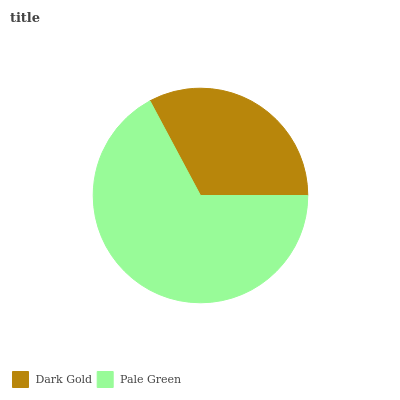Is Dark Gold the minimum?
Answer yes or no. Yes. Is Pale Green the maximum?
Answer yes or no. Yes. Is Pale Green the minimum?
Answer yes or no. No. Is Pale Green greater than Dark Gold?
Answer yes or no. Yes. Is Dark Gold less than Pale Green?
Answer yes or no. Yes. Is Dark Gold greater than Pale Green?
Answer yes or no. No. Is Pale Green less than Dark Gold?
Answer yes or no. No. Is Pale Green the high median?
Answer yes or no. Yes. Is Dark Gold the low median?
Answer yes or no. Yes. Is Dark Gold the high median?
Answer yes or no. No. Is Pale Green the low median?
Answer yes or no. No. 